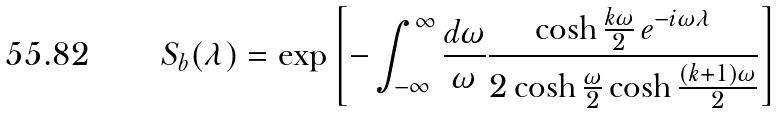<formula> <loc_0><loc_0><loc_500><loc_500>S _ { b } ( \lambda ) = \exp \left [ - \int _ { - \infty } ^ { \infty } \frac { d \omega } { \omega } \frac { \cosh \frac { k \omega } { 2 } \, e ^ { - i \omega \lambda } } { 2 \cosh \frac { \omega } { 2 } \cosh \frac { ( k + 1 ) \omega } { 2 } } \right ]</formula> 